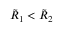<formula> <loc_0><loc_0><loc_500><loc_500>\tilde { R } _ { 1 } < \tilde { R } _ { 2 }</formula> 